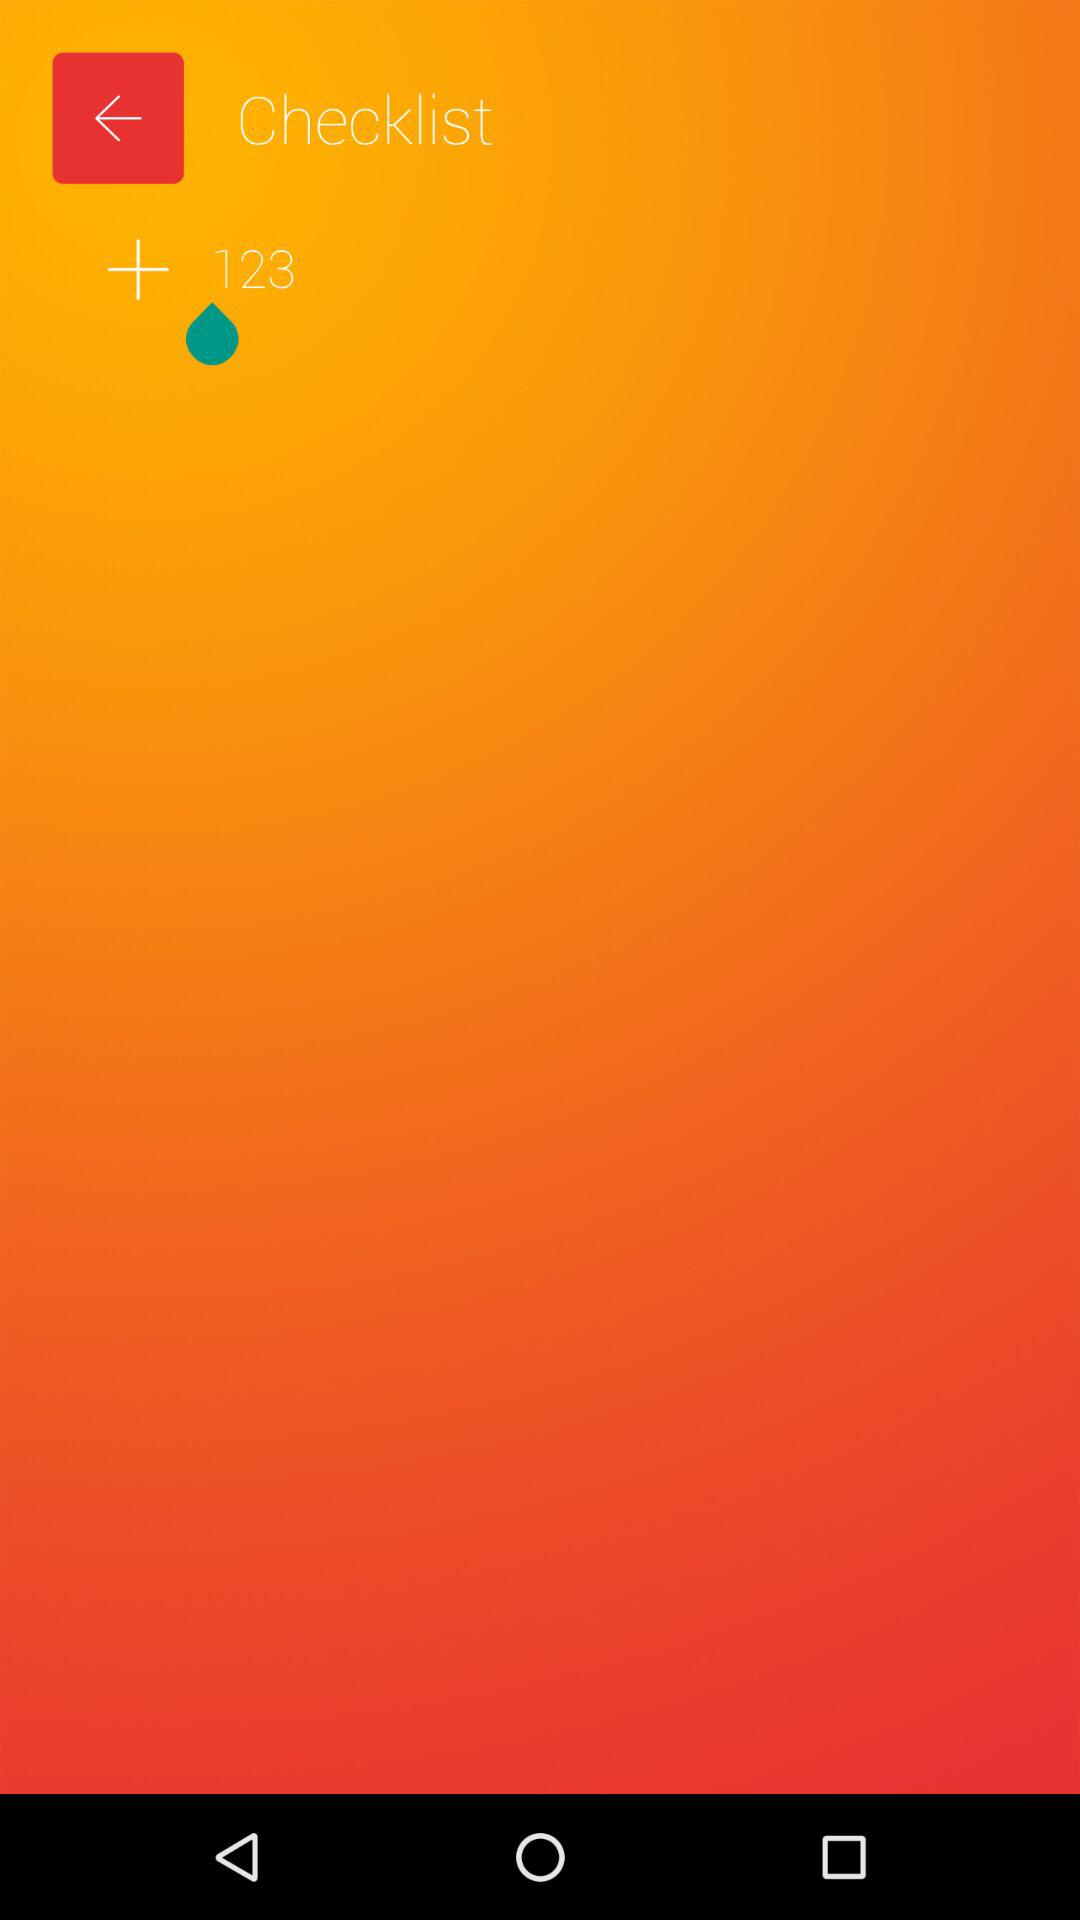Which number is on the checklist? The number that is on the checklist is "+ 123". 